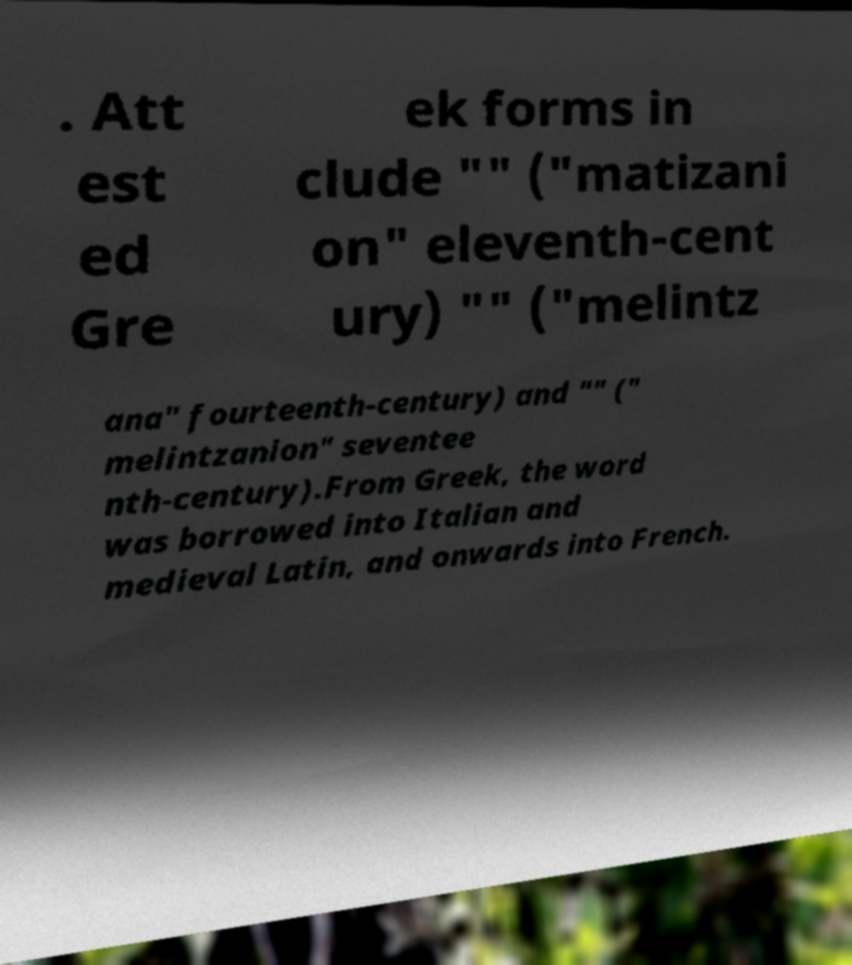Could you extract and type out the text from this image? . Att est ed Gre ek forms in clude "" ("matizani on" eleventh-cent ury) "" ("melintz ana" fourteenth-century) and "" (" melintzanion" seventee nth-century).From Greek, the word was borrowed into Italian and medieval Latin, and onwards into French. 